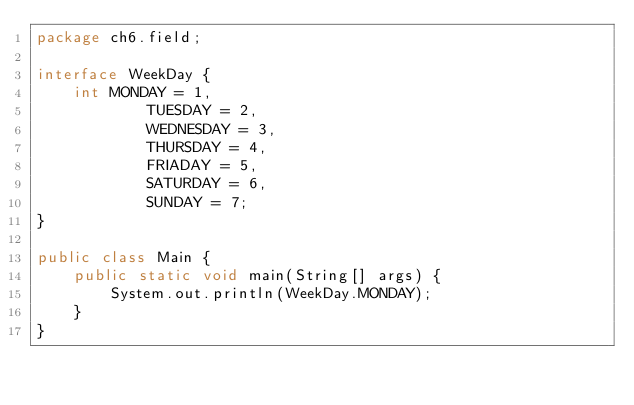<code> <loc_0><loc_0><loc_500><loc_500><_Java_>package ch6.field;

interface WeekDay {
    int MONDAY = 1,
            TUESDAY = 2,
            WEDNESDAY = 3,
            THURSDAY = 4,
            FRIADAY = 5,
            SATURDAY = 6,
            SUNDAY = 7;
}

public class Main {
    public static void main(String[] args) {
        System.out.println(WeekDay.MONDAY);
    }
}
</code> 